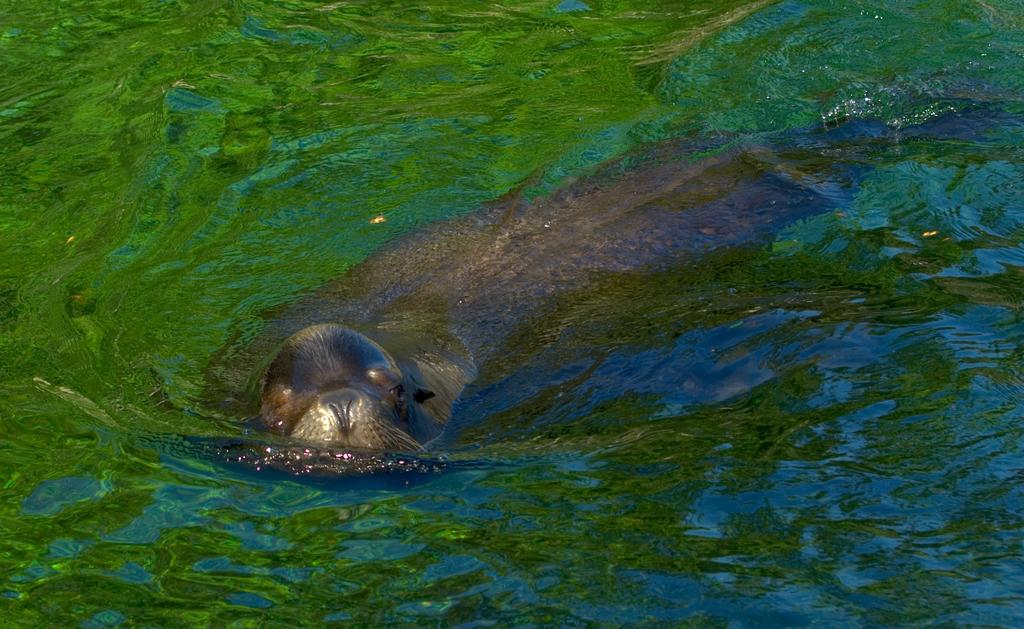What is the main subject of the image? There is a black color seal in the image. What is the seal doing in the image? The seal is swimming in the water. How can you describe the color of the water in the image? The water is green in color. Reasoning: Let' Let's think step by step in order to produce the conversation. We start by identifying the main subject of the image, which is the black color seal. Then, we describe the action of the seal, which is swimming in the water. Finally, we mention the color of the water, which is green. Each question is designed to elicit a specific detail about the image that is known from the provided facts. Absurd Question/Answer: What type of bag is the seal carrying on its journey in the image? There is no bag present in the image, and the seal is not on a journey; it is swimming in the water. What color is the pencil used by the seal to draw in the image? There is no pencil present in the image, and seals do not draw. 